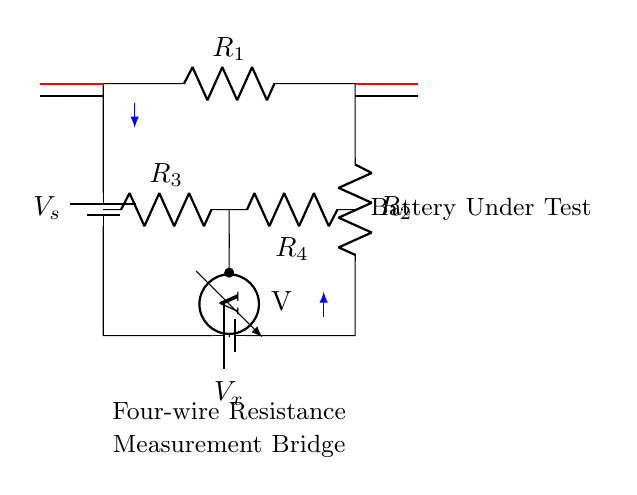What is the power source in this circuit? The power source is a battery, indicated as \(V_s\) at the top of the circuit. It provides the necessary voltage for the operation of the bridge circuit.
Answer: battery What are the values of the resistors in the bridge? The resistors in the bridge are labeled as \(R_1\), \(R_2\), \(R_3\), and \(R_4\) but the specific numerical values are not provided in the circuit diagram. They serve critical roles in creating a balanced condition in the measurement.
Answer: \(R_1, R_2, R_3, R_4\) (unspecified values) What is the purpose of the voltmeter in the circuit? The voltmeter measures the voltage difference between the two midpoints of the bridge formed by resistors \(R_3\) and \(R_4\), which helps in determining the balance condition needed for accurate resistance measurement.
Answer: Measure voltage How is the current flow indicated in this circuit? The current flow is indicated by blue arrows that point in the direction of current, showing how it moves through the various components of the circuit from the battery towards the resistors.
Answer: Arrows What type of measurement does this bridge perform? This bridge performs resistance measurement, specifically using a four-wire method which reduces error from lead resistances, critical for accurate battery testing in renewable energy systems.
Answer: Resistance measurement What do the two separate sets of wiring represent in this circuit? The two separate sets of wiring, shown in red and black, represent the four-wire connections used for resistance measurement. The red connections serve as current carrying leads, while the black connections are for voltage measurement, minimizing the error due to wire resistance.
Answer: Four-wire connections 